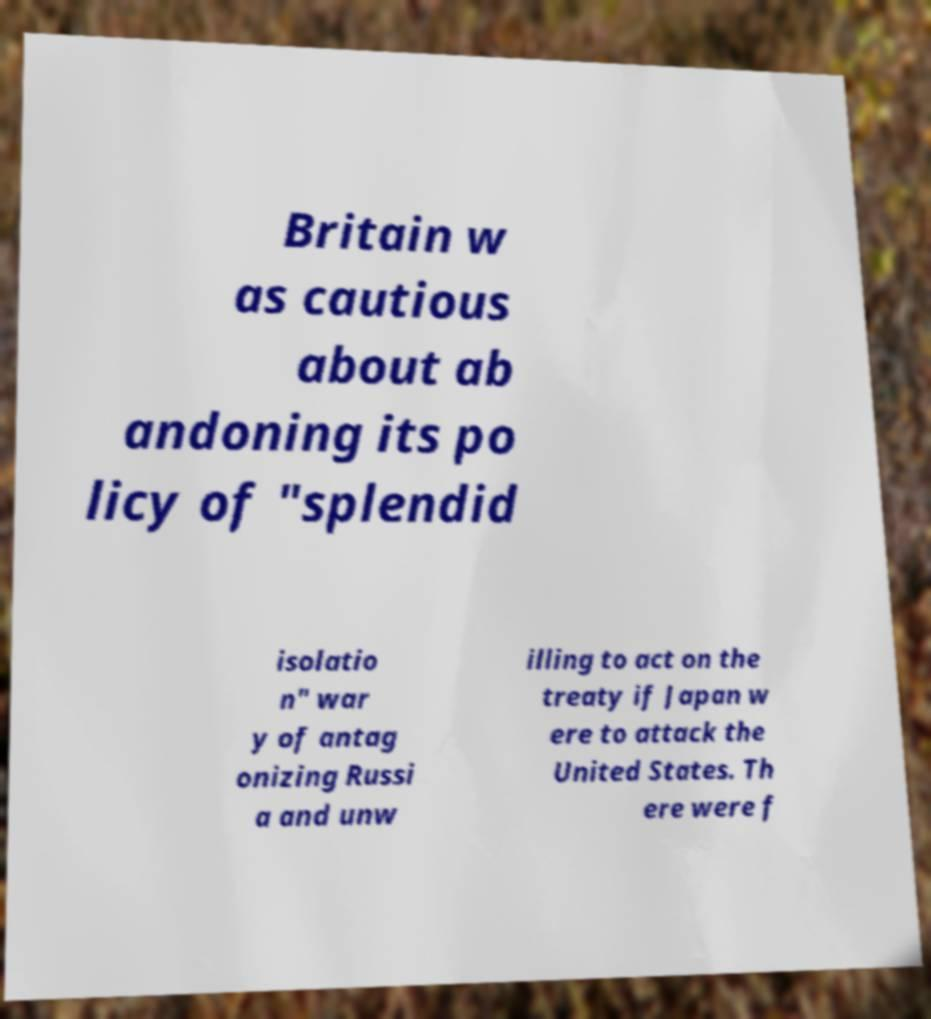For documentation purposes, I need the text within this image transcribed. Could you provide that? Britain w as cautious about ab andoning its po licy of "splendid isolatio n" war y of antag onizing Russi a and unw illing to act on the treaty if Japan w ere to attack the United States. Th ere were f 